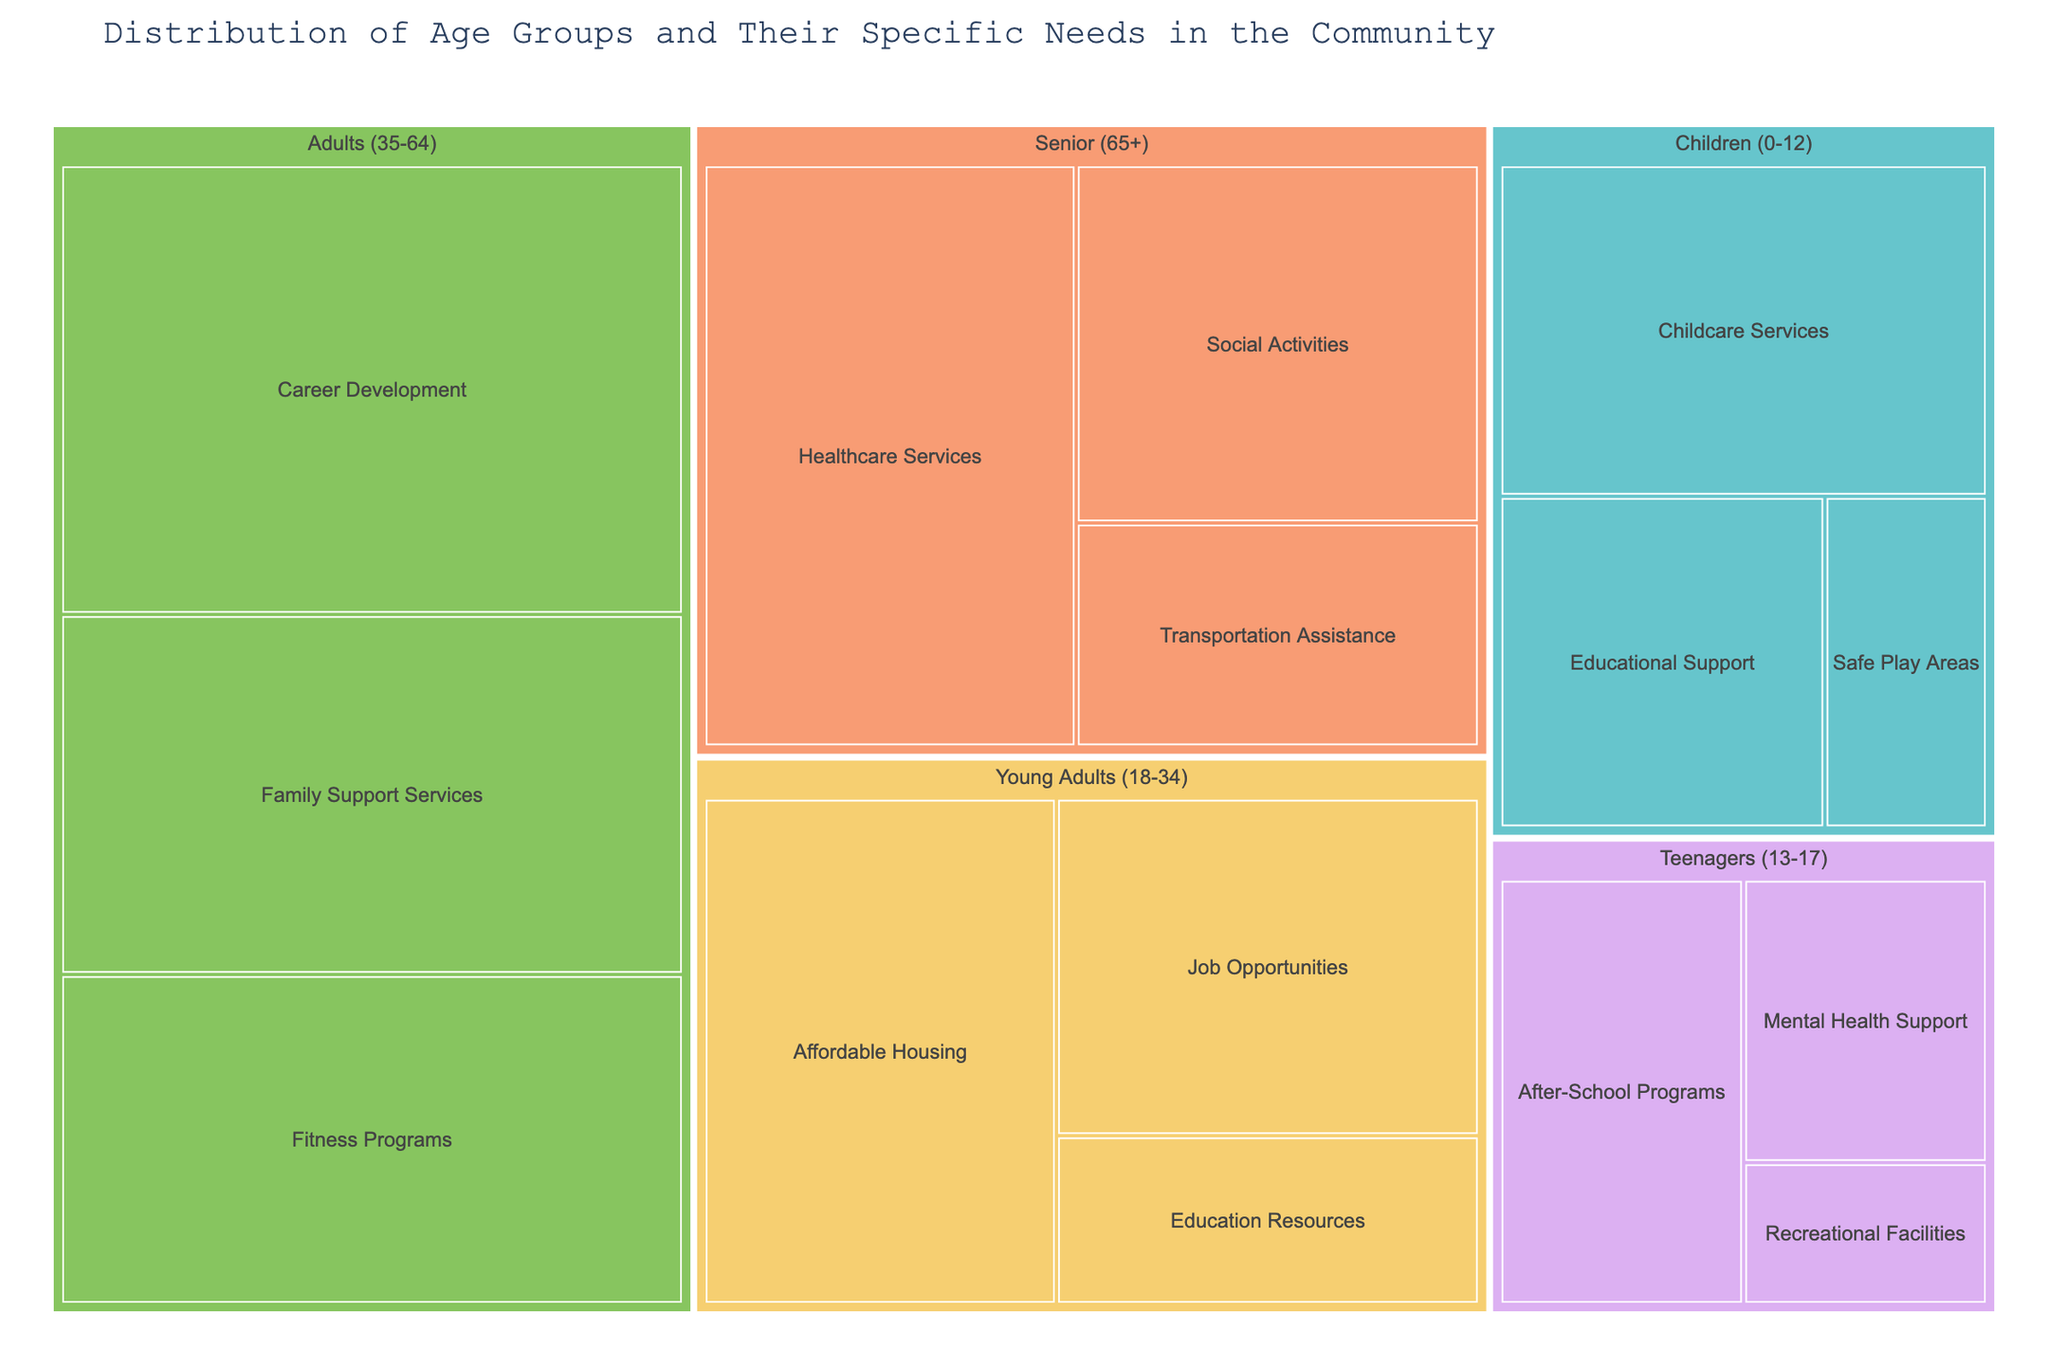What is the most significant specific need for young adults (18-34)? The Treemap shows that the largest section for young adults (18-34) corresponds to Affordable Housing with a value of 1000.
Answer: Affordable Housing Which age group has the highest total value of specific needs addressed? The Treemap shows the total value for each age group: Senior (65+): 1200+800+500=2500, Adults (35-64): 1500+1200+1100=3800, Young Adults (18-34): 1000+800+400=2200, Teenagers (13-17): 600+400+200=1200, Children (0-12): 900+600+300=1800. Adults (35-64) have the highest total value (3800).
Answer: Adults (35-64) What specific need has the smallest value for teenagers (13-17)? The smallest section for teenagers (13-17) in the Treemap corresponds to Recreational Facilities with a value of 200.
Answer: Recreational Facilities How many specific needs are addressed for each age group? The Treemap shows the number of sections per age group: Senior (65+): 3, Adults (35-64): 3, Young Adults (18-34): 3, Teenagers (13-17): 3, Children (0-12): 3. Each age group has 3 specific needs addressed.
Answer: 3 Which specific need within the Senior (65+) group has the lowest value? The Treemap indicates that the smallest section for the Senior (65+) group corresponds to Transportation Assistance with a value of 500.
Answer: Transportation Assistance What is the combined value of Family Support Services and Fitness Programs for adults (35-64)? The values are: Family Support Services (1200) and Fitness Programs (1100). Summing them up: 1200 + 1100 = 2300.
Answer: 2300 Which specific need in the Children (0-12) group has the second highest value? The specific needs in the Children (0-12) group are: Childcare Services (900), Educational Support (600), and Safe Play Areas (300). The second highest value corresponds to Educational Support (600).
Answer: Educational Support How many specific needs for Seniors (65+) have a value greater than 700? The values for specific needs in the Senior (65+) group are: Healthcare Services (1200), Social Activities (800), and Transportation Assistance (500). Two of these needs have values greater than 700 (Healthcare Services and Social Activities).
Answer: 2 Compare the value of Job Opportunities for young adults (18-34) and After-School Programs for teenagers (13-17). Which one is higher? The values are: Job Opportunities for young adults (800) and After-School Programs for teenagers (600). Job Opportunities have a higher value.
Answer: Job Opportunities 